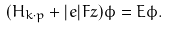Convert formula to latex. <formula><loc_0><loc_0><loc_500><loc_500>( { H } _ { k \cdot p } + | e | F z ) \phi = E \phi .</formula> 